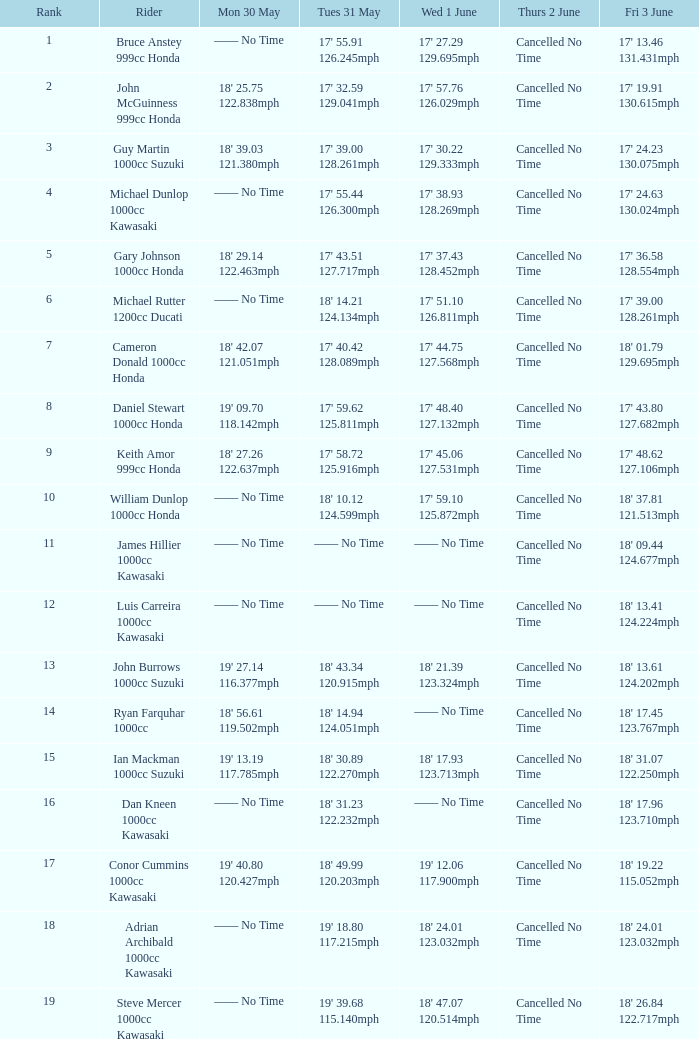554mph? Cancelled No Time. 